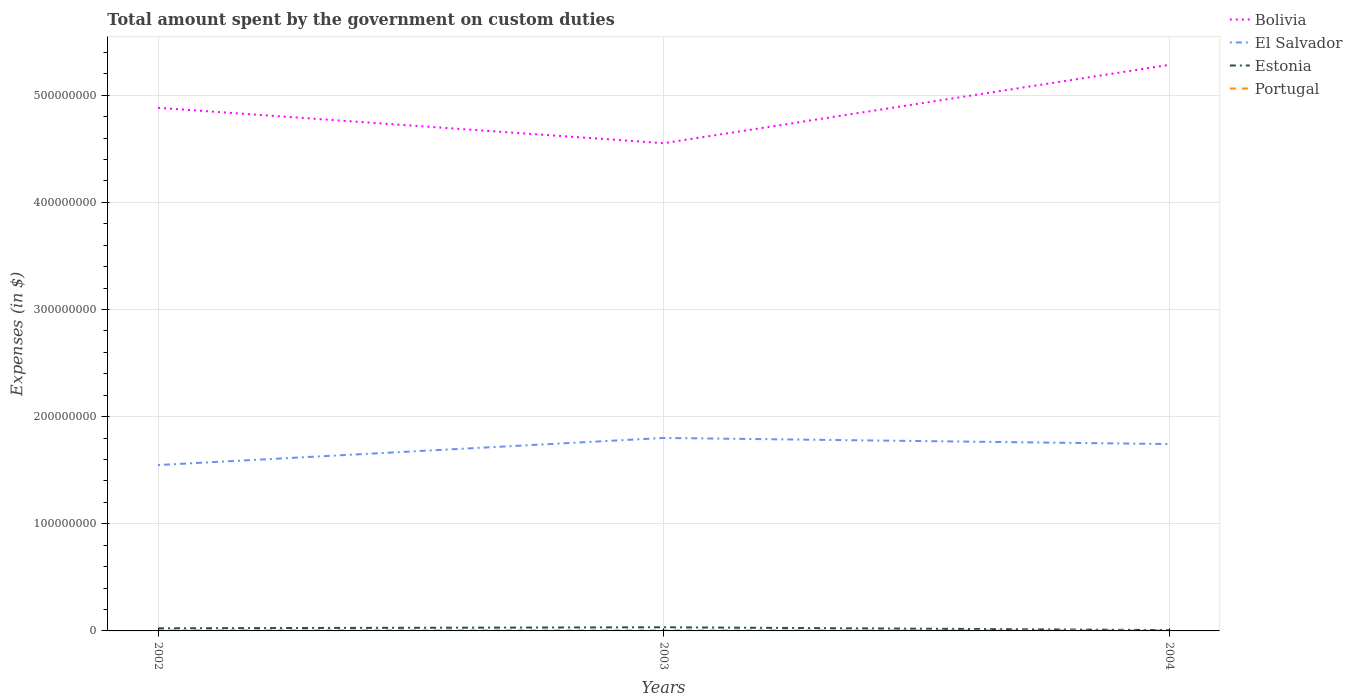How many different coloured lines are there?
Your answer should be compact. 4. Does the line corresponding to El Salvador intersect with the line corresponding to Portugal?
Your response must be concise. No. Across all years, what is the maximum amount spent on custom duties by the government in El Salvador?
Keep it short and to the point. 1.55e+08. What is the total amount spent on custom duties by the government in Portugal in the graph?
Ensure brevity in your answer.  -10000. What is the difference between the highest and the second highest amount spent on custom duties by the government in Bolivia?
Keep it short and to the point. 7.31e+07. How many years are there in the graph?
Offer a very short reply. 3. Does the graph contain any zero values?
Ensure brevity in your answer.  No. Does the graph contain grids?
Your response must be concise. Yes. What is the title of the graph?
Give a very brief answer. Total amount spent by the government on custom duties. Does "Chile" appear as one of the legend labels in the graph?
Offer a very short reply. No. What is the label or title of the Y-axis?
Your answer should be compact. Expenses (in $). What is the Expenses (in $) in Bolivia in 2002?
Ensure brevity in your answer.  4.88e+08. What is the Expenses (in $) in El Salvador in 2002?
Provide a succinct answer. 1.55e+08. What is the Expenses (in $) of Estonia in 2002?
Your answer should be very brief. 2.45e+06. What is the Expenses (in $) in Portugal in 2002?
Keep it short and to the point. 5.10e+05. What is the Expenses (in $) of Bolivia in 2003?
Your answer should be compact. 4.55e+08. What is the Expenses (in $) in El Salvador in 2003?
Provide a succinct answer. 1.80e+08. What is the Expenses (in $) in Estonia in 2003?
Your answer should be compact. 3.41e+06. What is the Expenses (in $) of Portugal in 2003?
Your answer should be compact. 4.20e+05. What is the Expenses (in $) in Bolivia in 2004?
Give a very brief answer. 5.28e+08. What is the Expenses (in $) of El Salvador in 2004?
Your answer should be compact. 1.74e+08. What is the Expenses (in $) in Estonia in 2004?
Your response must be concise. 7.80e+05. Across all years, what is the maximum Expenses (in $) of Bolivia?
Provide a short and direct response. 5.28e+08. Across all years, what is the maximum Expenses (in $) of El Salvador?
Your answer should be compact. 1.80e+08. Across all years, what is the maximum Expenses (in $) of Estonia?
Your response must be concise. 3.41e+06. Across all years, what is the maximum Expenses (in $) of Portugal?
Offer a terse response. 5.10e+05. Across all years, what is the minimum Expenses (in $) in Bolivia?
Make the answer very short. 4.55e+08. Across all years, what is the minimum Expenses (in $) in El Salvador?
Provide a succinct answer. 1.55e+08. Across all years, what is the minimum Expenses (in $) in Estonia?
Your answer should be compact. 7.80e+05. What is the total Expenses (in $) in Bolivia in the graph?
Provide a succinct answer. 1.47e+09. What is the total Expenses (in $) of El Salvador in the graph?
Give a very brief answer. 5.09e+08. What is the total Expenses (in $) in Estonia in the graph?
Keep it short and to the point. 6.64e+06. What is the total Expenses (in $) in Portugal in the graph?
Offer a terse response. 1.36e+06. What is the difference between the Expenses (in $) in Bolivia in 2002 and that in 2003?
Provide a succinct answer. 3.30e+07. What is the difference between the Expenses (in $) in El Salvador in 2002 and that in 2003?
Make the answer very short. -2.53e+07. What is the difference between the Expenses (in $) in Estonia in 2002 and that in 2003?
Provide a short and direct response. -9.60e+05. What is the difference between the Expenses (in $) of Portugal in 2002 and that in 2003?
Offer a terse response. 9.00e+04. What is the difference between the Expenses (in $) of Bolivia in 2002 and that in 2004?
Provide a succinct answer. -4.01e+07. What is the difference between the Expenses (in $) in El Salvador in 2002 and that in 2004?
Provide a succinct answer. -1.96e+07. What is the difference between the Expenses (in $) in Estonia in 2002 and that in 2004?
Ensure brevity in your answer.  1.67e+06. What is the difference between the Expenses (in $) of Bolivia in 2003 and that in 2004?
Provide a short and direct response. -7.31e+07. What is the difference between the Expenses (in $) of El Salvador in 2003 and that in 2004?
Provide a succinct answer. 5.70e+06. What is the difference between the Expenses (in $) in Estonia in 2003 and that in 2004?
Ensure brevity in your answer.  2.63e+06. What is the difference between the Expenses (in $) in Bolivia in 2002 and the Expenses (in $) in El Salvador in 2003?
Keep it short and to the point. 3.08e+08. What is the difference between the Expenses (in $) of Bolivia in 2002 and the Expenses (in $) of Estonia in 2003?
Ensure brevity in your answer.  4.85e+08. What is the difference between the Expenses (in $) of Bolivia in 2002 and the Expenses (in $) of Portugal in 2003?
Your answer should be compact. 4.88e+08. What is the difference between the Expenses (in $) in El Salvador in 2002 and the Expenses (in $) in Estonia in 2003?
Offer a very short reply. 1.51e+08. What is the difference between the Expenses (in $) in El Salvador in 2002 and the Expenses (in $) in Portugal in 2003?
Offer a very short reply. 1.54e+08. What is the difference between the Expenses (in $) in Estonia in 2002 and the Expenses (in $) in Portugal in 2003?
Your response must be concise. 2.03e+06. What is the difference between the Expenses (in $) in Bolivia in 2002 and the Expenses (in $) in El Salvador in 2004?
Your answer should be compact. 3.14e+08. What is the difference between the Expenses (in $) of Bolivia in 2002 and the Expenses (in $) of Estonia in 2004?
Your answer should be compact. 4.87e+08. What is the difference between the Expenses (in $) in Bolivia in 2002 and the Expenses (in $) in Portugal in 2004?
Make the answer very short. 4.88e+08. What is the difference between the Expenses (in $) of El Salvador in 2002 and the Expenses (in $) of Estonia in 2004?
Give a very brief answer. 1.54e+08. What is the difference between the Expenses (in $) of El Salvador in 2002 and the Expenses (in $) of Portugal in 2004?
Your answer should be very brief. 1.54e+08. What is the difference between the Expenses (in $) of Estonia in 2002 and the Expenses (in $) of Portugal in 2004?
Provide a short and direct response. 2.02e+06. What is the difference between the Expenses (in $) of Bolivia in 2003 and the Expenses (in $) of El Salvador in 2004?
Make the answer very short. 2.81e+08. What is the difference between the Expenses (in $) of Bolivia in 2003 and the Expenses (in $) of Estonia in 2004?
Give a very brief answer. 4.54e+08. What is the difference between the Expenses (in $) in Bolivia in 2003 and the Expenses (in $) in Portugal in 2004?
Provide a short and direct response. 4.55e+08. What is the difference between the Expenses (in $) of El Salvador in 2003 and the Expenses (in $) of Estonia in 2004?
Make the answer very short. 1.79e+08. What is the difference between the Expenses (in $) in El Salvador in 2003 and the Expenses (in $) in Portugal in 2004?
Ensure brevity in your answer.  1.80e+08. What is the difference between the Expenses (in $) of Estonia in 2003 and the Expenses (in $) of Portugal in 2004?
Your response must be concise. 2.98e+06. What is the average Expenses (in $) of Bolivia per year?
Give a very brief answer. 4.91e+08. What is the average Expenses (in $) in El Salvador per year?
Your response must be concise. 1.70e+08. What is the average Expenses (in $) in Estonia per year?
Provide a succinct answer. 2.21e+06. What is the average Expenses (in $) of Portugal per year?
Offer a terse response. 4.53e+05. In the year 2002, what is the difference between the Expenses (in $) in Bolivia and Expenses (in $) in El Salvador?
Keep it short and to the point. 3.33e+08. In the year 2002, what is the difference between the Expenses (in $) in Bolivia and Expenses (in $) in Estonia?
Make the answer very short. 4.86e+08. In the year 2002, what is the difference between the Expenses (in $) in Bolivia and Expenses (in $) in Portugal?
Offer a terse response. 4.88e+08. In the year 2002, what is the difference between the Expenses (in $) in El Salvador and Expenses (in $) in Estonia?
Ensure brevity in your answer.  1.52e+08. In the year 2002, what is the difference between the Expenses (in $) in El Salvador and Expenses (in $) in Portugal?
Provide a succinct answer. 1.54e+08. In the year 2002, what is the difference between the Expenses (in $) in Estonia and Expenses (in $) in Portugal?
Offer a very short reply. 1.94e+06. In the year 2003, what is the difference between the Expenses (in $) in Bolivia and Expenses (in $) in El Salvador?
Offer a very short reply. 2.75e+08. In the year 2003, what is the difference between the Expenses (in $) of Bolivia and Expenses (in $) of Estonia?
Ensure brevity in your answer.  4.52e+08. In the year 2003, what is the difference between the Expenses (in $) of Bolivia and Expenses (in $) of Portugal?
Your response must be concise. 4.55e+08. In the year 2003, what is the difference between the Expenses (in $) in El Salvador and Expenses (in $) in Estonia?
Your answer should be compact. 1.77e+08. In the year 2003, what is the difference between the Expenses (in $) of El Salvador and Expenses (in $) of Portugal?
Your answer should be very brief. 1.80e+08. In the year 2003, what is the difference between the Expenses (in $) of Estonia and Expenses (in $) of Portugal?
Provide a short and direct response. 2.99e+06. In the year 2004, what is the difference between the Expenses (in $) of Bolivia and Expenses (in $) of El Salvador?
Provide a short and direct response. 3.54e+08. In the year 2004, what is the difference between the Expenses (in $) in Bolivia and Expenses (in $) in Estonia?
Keep it short and to the point. 5.28e+08. In the year 2004, what is the difference between the Expenses (in $) of Bolivia and Expenses (in $) of Portugal?
Your answer should be compact. 5.28e+08. In the year 2004, what is the difference between the Expenses (in $) in El Salvador and Expenses (in $) in Estonia?
Make the answer very short. 1.74e+08. In the year 2004, what is the difference between the Expenses (in $) of El Salvador and Expenses (in $) of Portugal?
Give a very brief answer. 1.74e+08. What is the ratio of the Expenses (in $) in Bolivia in 2002 to that in 2003?
Provide a short and direct response. 1.07. What is the ratio of the Expenses (in $) of El Salvador in 2002 to that in 2003?
Keep it short and to the point. 0.86. What is the ratio of the Expenses (in $) in Estonia in 2002 to that in 2003?
Your answer should be very brief. 0.72. What is the ratio of the Expenses (in $) in Portugal in 2002 to that in 2003?
Offer a very short reply. 1.21. What is the ratio of the Expenses (in $) of Bolivia in 2002 to that in 2004?
Give a very brief answer. 0.92. What is the ratio of the Expenses (in $) in El Salvador in 2002 to that in 2004?
Your response must be concise. 0.89. What is the ratio of the Expenses (in $) in Estonia in 2002 to that in 2004?
Your answer should be very brief. 3.14. What is the ratio of the Expenses (in $) in Portugal in 2002 to that in 2004?
Your response must be concise. 1.19. What is the ratio of the Expenses (in $) of Bolivia in 2003 to that in 2004?
Your response must be concise. 0.86. What is the ratio of the Expenses (in $) in El Salvador in 2003 to that in 2004?
Your answer should be very brief. 1.03. What is the ratio of the Expenses (in $) of Estonia in 2003 to that in 2004?
Offer a very short reply. 4.37. What is the ratio of the Expenses (in $) of Portugal in 2003 to that in 2004?
Your response must be concise. 0.98. What is the difference between the highest and the second highest Expenses (in $) in Bolivia?
Provide a short and direct response. 4.01e+07. What is the difference between the highest and the second highest Expenses (in $) of El Salvador?
Offer a terse response. 5.70e+06. What is the difference between the highest and the second highest Expenses (in $) of Estonia?
Provide a short and direct response. 9.60e+05. What is the difference between the highest and the lowest Expenses (in $) of Bolivia?
Keep it short and to the point. 7.31e+07. What is the difference between the highest and the lowest Expenses (in $) of El Salvador?
Make the answer very short. 2.53e+07. What is the difference between the highest and the lowest Expenses (in $) of Estonia?
Offer a terse response. 2.63e+06. What is the difference between the highest and the lowest Expenses (in $) of Portugal?
Offer a very short reply. 9.00e+04. 